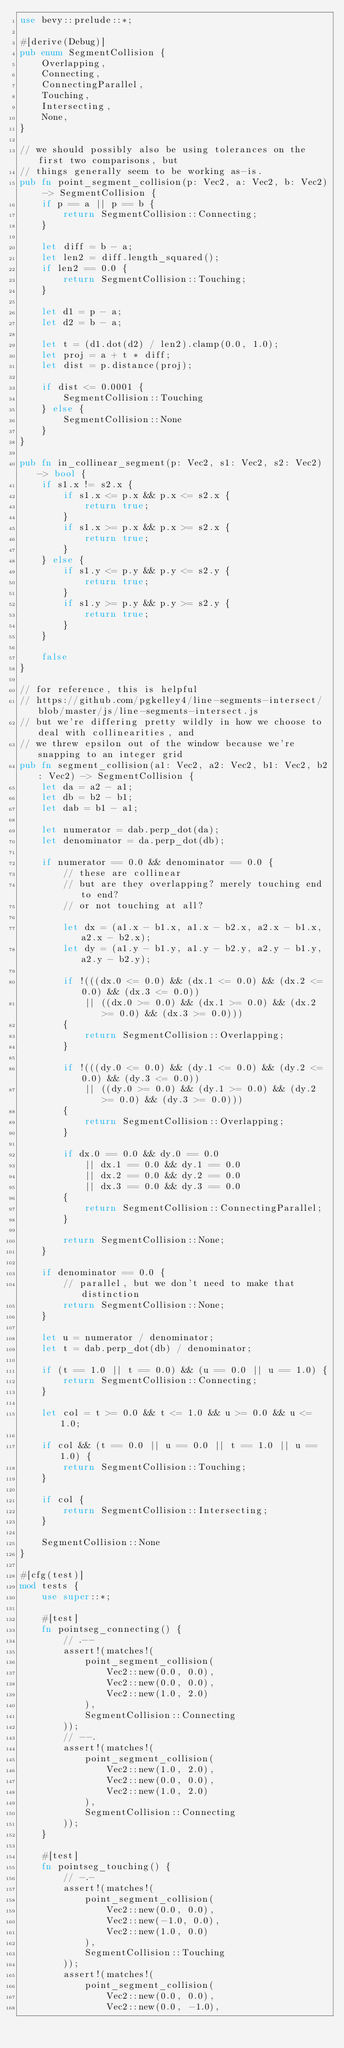<code> <loc_0><loc_0><loc_500><loc_500><_Rust_>use bevy::prelude::*;

#[derive(Debug)]
pub enum SegmentCollision {
    Overlapping,
    Connecting,
    ConnectingParallel,
    Touching,
    Intersecting,
    None,
}

// we should possibly also be using tolerances on the first two comparisons, but
// things generally seem to be working as-is.
pub fn point_segment_collision(p: Vec2, a: Vec2, b: Vec2) -> SegmentCollision {
    if p == a || p == b {
        return SegmentCollision::Connecting;
    }

    let diff = b - a;
    let len2 = diff.length_squared();
    if len2 == 0.0 {
        return SegmentCollision::Touching;
    }

    let d1 = p - a;
    let d2 = b - a;

    let t = (d1.dot(d2) / len2).clamp(0.0, 1.0);
    let proj = a + t * diff;
    let dist = p.distance(proj);

    if dist <= 0.0001 {
        SegmentCollision::Touching
    } else {
        SegmentCollision::None
    }
}

pub fn in_collinear_segment(p: Vec2, s1: Vec2, s2: Vec2) -> bool {
    if s1.x != s2.x {
        if s1.x <= p.x && p.x <= s2.x {
            return true;
        }
        if s1.x >= p.x && p.x >= s2.x {
            return true;
        }
    } else {
        if s1.y <= p.y && p.y <= s2.y {
            return true;
        }
        if s1.y >= p.y && p.y >= s2.y {
            return true;
        }
    }

    false
}

// for reference, this is helpful
// https://github.com/pgkelley4/line-segments-intersect/blob/master/js/line-segments-intersect.js
// but we're differing pretty wildly in how we choose to deal with collinearities, and
// we threw epsilon out of the window because we're snapping to an integer grid
pub fn segment_collision(a1: Vec2, a2: Vec2, b1: Vec2, b2: Vec2) -> SegmentCollision {
    let da = a2 - a1;
    let db = b2 - b1;
    let dab = b1 - a1;

    let numerator = dab.perp_dot(da);
    let denominator = da.perp_dot(db);

    if numerator == 0.0 && denominator == 0.0 {
        // these are collinear
        // but are they overlapping? merely touching end to end?
        // or not touching at all?

        let dx = (a1.x - b1.x, a1.x - b2.x, a2.x - b1.x, a2.x - b2.x);
        let dy = (a1.y - b1.y, a1.y - b2.y, a2.y - b1.y, a2.y - b2.y);

        if !(((dx.0 <= 0.0) && (dx.1 <= 0.0) && (dx.2 <= 0.0) && (dx.3 <= 0.0))
            || ((dx.0 >= 0.0) && (dx.1 >= 0.0) && (dx.2 >= 0.0) && (dx.3 >= 0.0)))
        {
            return SegmentCollision::Overlapping;
        }

        if !(((dy.0 <= 0.0) && (dy.1 <= 0.0) && (dy.2 <= 0.0) && (dy.3 <= 0.0))
            || ((dy.0 >= 0.0) && (dy.1 >= 0.0) && (dy.2 >= 0.0) && (dy.3 >= 0.0)))
        {
            return SegmentCollision::Overlapping;
        }

        if dx.0 == 0.0 && dy.0 == 0.0
            || dx.1 == 0.0 && dy.1 == 0.0
            || dx.2 == 0.0 && dy.2 == 0.0
            || dx.3 == 0.0 && dy.3 == 0.0
        {
            return SegmentCollision::ConnectingParallel;
        }

        return SegmentCollision::None;
    }

    if denominator == 0.0 {
        // parallel, but we don't need to make that distinction
        return SegmentCollision::None;
    }

    let u = numerator / denominator;
    let t = dab.perp_dot(db) / denominator;

    if (t == 1.0 || t == 0.0) && (u == 0.0 || u == 1.0) {
        return SegmentCollision::Connecting;
    }

    let col = t >= 0.0 && t <= 1.0 && u >= 0.0 && u <= 1.0;

    if col && (t == 0.0 || u == 0.0 || t == 1.0 || u == 1.0) {
        return SegmentCollision::Touching;
    }

    if col {
        return SegmentCollision::Intersecting;
    }

    SegmentCollision::None
}

#[cfg(test)]
mod tests {
    use super::*;

    #[test]
    fn pointseg_connecting() {
        // .--
        assert!(matches!(
            point_segment_collision(
                Vec2::new(0.0, 0.0),
                Vec2::new(0.0, 0.0),
                Vec2::new(1.0, 2.0)
            ),
            SegmentCollision::Connecting
        ));
        // --.
        assert!(matches!(
            point_segment_collision(
                Vec2::new(1.0, 2.0),
                Vec2::new(0.0, 0.0),
                Vec2::new(1.0, 2.0)
            ),
            SegmentCollision::Connecting
        ));
    }

    #[test]
    fn pointseg_touching() {
        // -.-
        assert!(matches!(
            point_segment_collision(
                Vec2::new(0.0, 0.0),
                Vec2::new(-1.0, 0.0),
                Vec2::new(1.0, 0.0)
            ),
            SegmentCollision::Touching
        ));
        assert!(matches!(
            point_segment_collision(
                Vec2::new(0.0, 0.0),
                Vec2::new(0.0, -1.0),</code> 